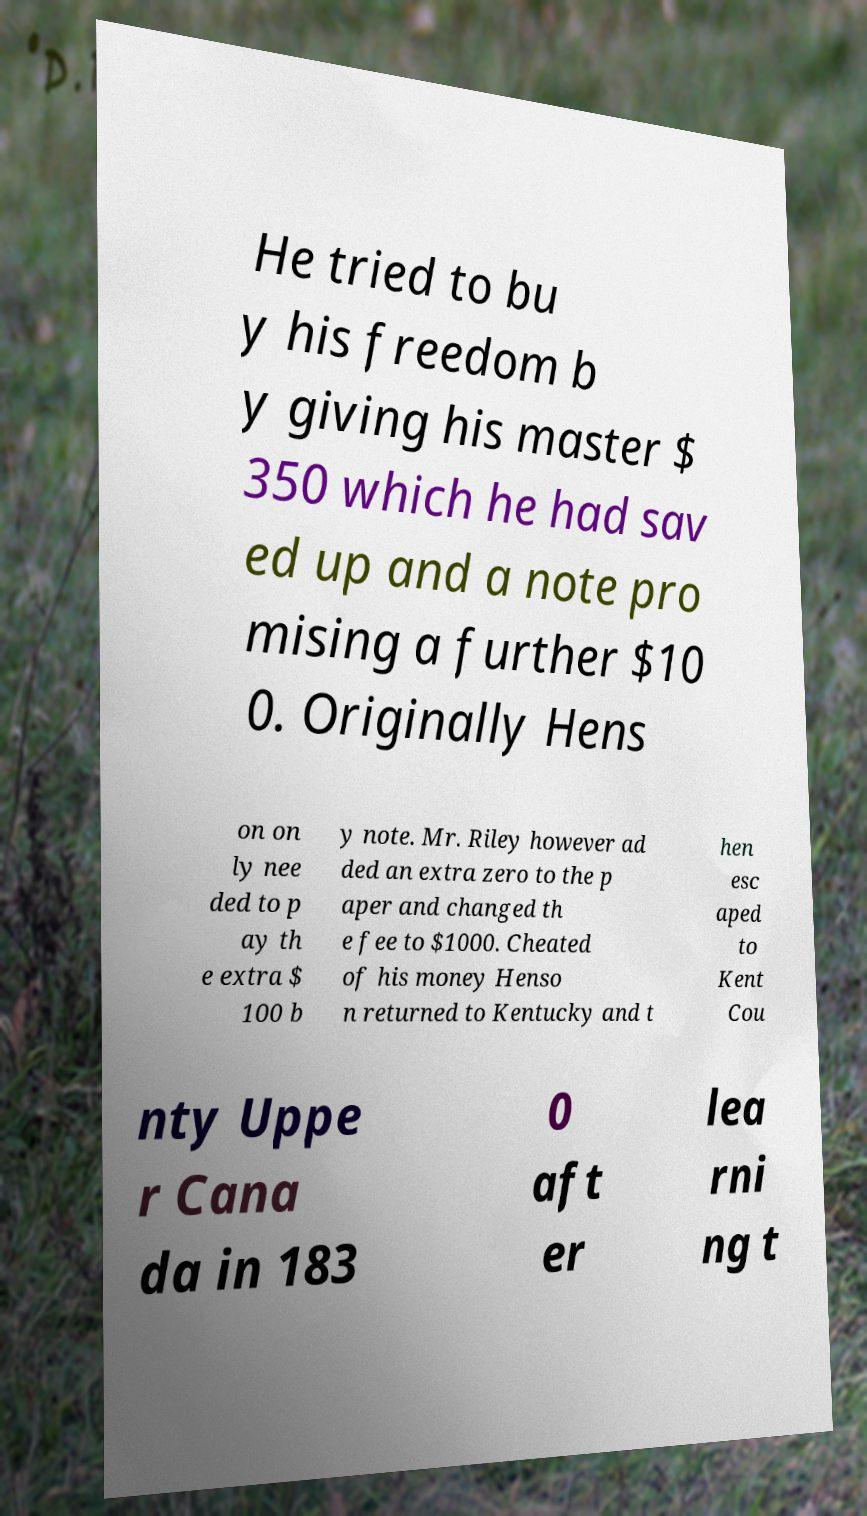Please identify and transcribe the text found in this image. He tried to bu y his freedom b y giving his master $ 350 which he had sav ed up and a note pro mising a further $10 0. Originally Hens on on ly nee ded to p ay th e extra $ 100 b y note. Mr. Riley however ad ded an extra zero to the p aper and changed th e fee to $1000. Cheated of his money Henso n returned to Kentucky and t hen esc aped to Kent Cou nty Uppe r Cana da in 183 0 aft er lea rni ng t 